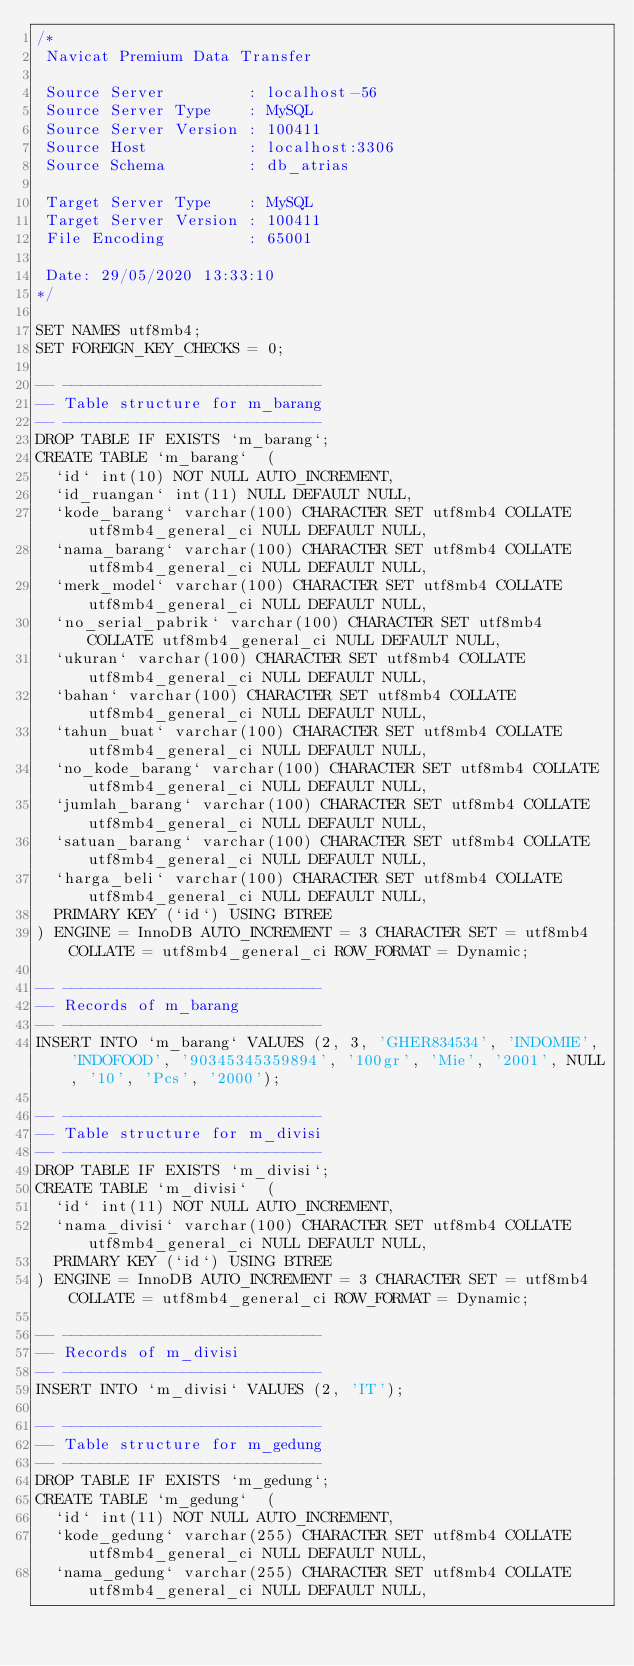<code> <loc_0><loc_0><loc_500><loc_500><_SQL_>/*
 Navicat Premium Data Transfer

 Source Server         : localhost-56
 Source Server Type    : MySQL
 Source Server Version : 100411
 Source Host           : localhost:3306
 Source Schema         : db_atrias

 Target Server Type    : MySQL
 Target Server Version : 100411
 File Encoding         : 65001

 Date: 29/05/2020 13:33:10
*/

SET NAMES utf8mb4;
SET FOREIGN_KEY_CHECKS = 0;

-- ----------------------------
-- Table structure for m_barang
-- ----------------------------
DROP TABLE IF EXISTS `m_barang`;
CREATE TABLE `m_barang`  (
  `id` int(10) NOT NULL AUTO_INCREMENT,
  `id_ruangan` int(11) NULL DEFAULT NULL,
  `kode_barang` varchar(100) CHARACTER SET utf8mb4 COLLATE utf8mb4_general_ci NULL DEFAULT NULL,
  `nama_barang` varchar(100) CHARACTER SET utf8mb4 COLLATE utf8mb4_general_ci NULL DEFAULT NULL,
  `merk_model` varchar(100) CHARACTER SET utf8mb4 COLLATE utf8mb4_general_ci NULL DEFAULT NULL,
  `no_serial_pabrik` varchar(100) CHARACTER SET utf8mb4 COLLATE utf8mb4_general_ci NULL DEFAULT NULL,
  `ukuran` varchar(100) CHARACTER SET utf8mb4 COLLATE utf8mb4_general_ci NULL DEFAULT NULL,
  `bahan` varchar(100) CHARACTER SET utf8mb4 COLLATE utf8mb4_general_ci NULL DEFAULT NULL,
  `tahun_buat` varchar(100) CHARACTER SET utf8mb4 COLLATE utf8mb4_general_ci NULL DEFAULT NULL,
  `no_kode_barang` varchar(100) CHARACTER SET utf8mb4 COLLATE utf8mb4_general_ci NULL DEFAULT NULL,
  `jumlah_barang` varchar(100) CHARACTER SET utf8mb4 COLLATE utf8mb4_general_ci NULL DEFAULT NULL,
  `satuan_barang` varchar(100) CHARACTER SET utf8mb4 COLLATE utf8mb4_general_ci NULL DEFAULT NULL,
  `harga_beli` varchar(100) CHARACTER SET utf8mb4 COLLATE utf8mb4_general_ci NULL DEFAULT NULL,
  PRIMARY KEY (`id`) USING BTREE
) ENGINE = InnoDB AUTO_INCREMENT = 3 CHARACTER SET = utf8mb4 COLLATE = utf8mb4_general_ci ROW_FORMAT = Dynamic;

-- ----------------------------
-- Records of m_barang
-- ----------------------------
INSERT INTO `m_barang` VALUES (2, 3, 'GHER834534', 'INDOMIE', 'INDOFOOD', '90345345359894', '100gr', 'Mie', '2001', NULL, '10', 'Pcs', '2000');

-- ----------------------------
-- Table structure for m_divisi
-- ----------------------------
DROP TABLE IF EXISTS `m_divisi`;
CREATE TABLE `m_divisi`  (
  `id` int(11) NOT NULL AUTO_INCREMENT,
  `nama_divisi` varchar(100) CHARACTER SET utf8mb4 COLLATE utf8mb4_general_ci NULL DEFAULT NULL,
  PRIMARY KEY (`id`) USING BTREE
) ENGINE = InnoDB AUTO_INCREMENT = 3 CHARACTER SET = utf8mb4 COLLATE = utf8mb4_general_ci ROW_FORMAT = Dynamic;

-- ----------------------------
-- Records of m_divisi
-- ----------------------------
INSERT INTO `m_divisi` VALUES (2, 'IT');

-- ----------------------------
-- Table structure for m_gedung
-- ----------------------------
DROP TABLE IF EXISTS `m_gedung`;
CREATE TABLE `m_gedung`  (
  `id` int(11) NOT NULL AUTO_INCREMENT,
  `kode_gedung` varchar(255) CHARACTER SET utf8mb4 COLLATE utf8mb4_general_ci NULL DEFAULT NULL,
  `nama_gedung` varchar(255) CHARACTER SET utf8mb4 COLLATE utf8mb4_general_ci NULL DEFAULT NULL,</code> 